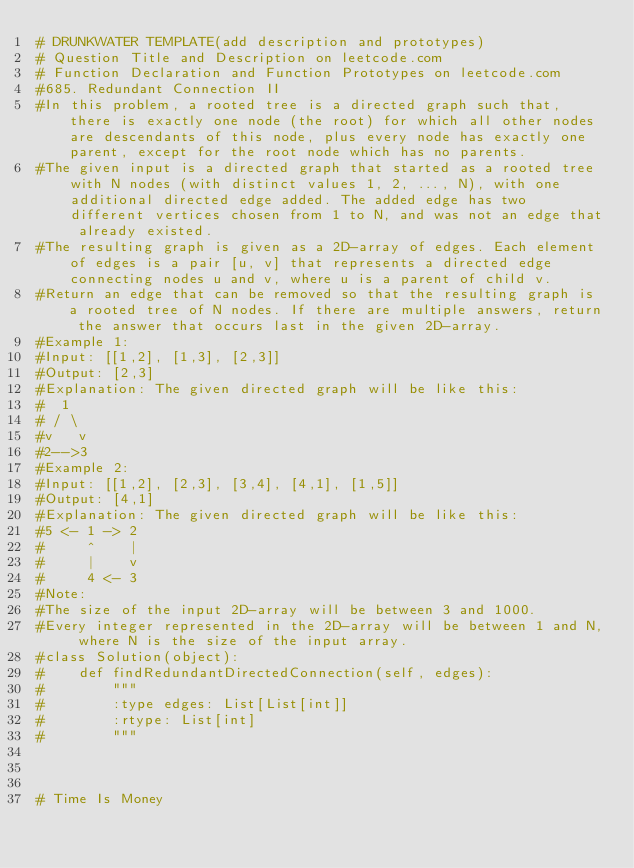<code> <loc_0><loc_0><loc_500><loc_500><_Python_># DRUNKWATER TEMPLATE(add description and prototypes)
# Question Title and Description on leetcode.com
# Function Declaration and Function Prototypes on leetcode.com
#685. Redundant Connection II
#In this problem, a rooted tree is a directed graph such that, there is exactly one node (the root) for which all other nodes are descendants of this node, plus every node has exactly one parent, except for the root node which has no parents.
#The given input is a directed graph that started as a rooted tree with N nodes (with distinct values 1, 2, ..., N), with one additional directed edge added. The added edge has two different vertices chosen from 1 to N, and was not an edge that already existed.
#The resulting graph is given as a 2D-array of edges. Each element of edges is a pair [u, v] that represents a directed edge connecting nodes u and v, where u is a parent of child v.
#Return an edge that can be removed so that the resulting graph is a rooted tree of N nodes. If there are multiple answers, return the answer that occurs last in the given 2D-array.
#Example 1:
#Input: [[1,2], [1,3], [2,3]]
#Output: [2,3]
#Explanation: The given directed graph will be like this:
#  1
# / \
#v   v
#2-->3
#Example 2:
#Input: [[1,2], [2,3], [3,4], [4,1], [1,5]]
#Output: [4,1]
#Explanation: The given directed graph will be like this:
#5 <- 1 -> 2
#     ^    |
#     |    v
#     4 <- 3
#Note:
#The size of the input 2D-array will be between 3 and 1000.
#Every integer represented in the 2D-array will be between 1 and N, where N is the size of the input array.
#class Solution(object):
#    def findRedundantDirectedConnection(self, edges):
#        """
#        :type edges: List[List[int]]
#        :rtype: List[int]
#        """



# Time Is Money</code> 